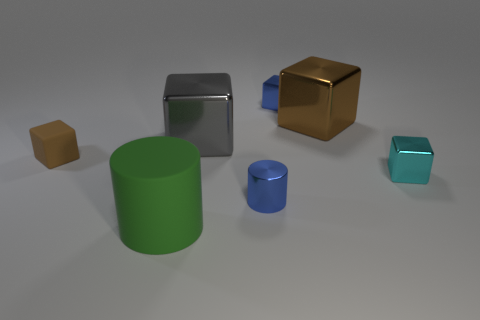Do the tiny cube right of the brown metallic cube and the tiny blue cylinder to the left of the brown shiny object have the same material? It appears that the tiny cube to the right of the brown metallic cube and the tiny blue cylinder to the left of the brown shiny object do not share the same material. The tiny cube exhibits a glossy surface suggesting a material like polished stone or coated plastic, while the blue cylinder has a different hue and a matte finish, indicating a dissimilar material, possibly an uncoated or painted metal or plastic. 